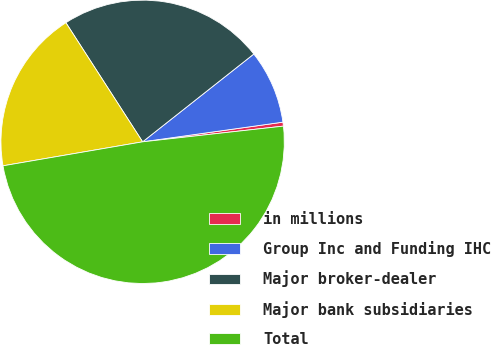Convert chart to OTSL. <chart><loc_0><loc_0><loc_500><loc_500><pie_chart><fcel>in millions<fcel>Group Inc and Funding IHC<fcel>Major broker-dealer<fcel>Major bank subsidiaries<fcel>Total<nl><fcel>0.45%<fcel>8.42%<fcel>23.47%<fcel>18.6%<fcel>49.06%<nl></chart> 